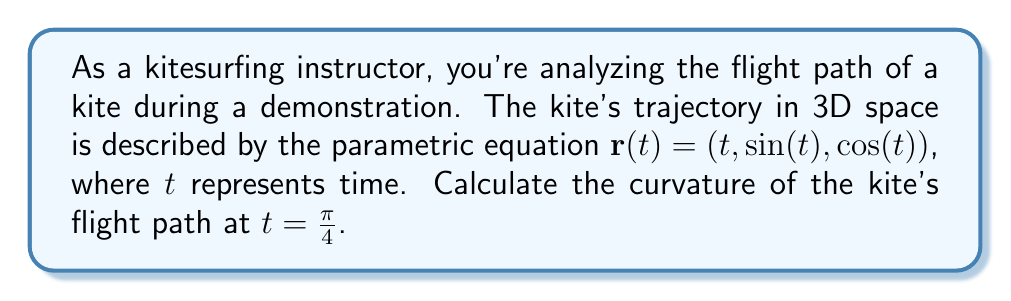Solve this math problem. To determine the curvature of the kite's flight path, we'll use differential geometry and follow these steps:

1) The curvature $\kappa$ is given by the formula:

   $$\kappa = \frac{|\mathbf{r}'(t) \times \mathbf{r}''(t)|}{|\mathbf{r}'(t)|^3}$$

2) First, let's calculate $\mathbf{r}'(t)$:
   $$\mathbf{r}'(t) = (1, \cos(t), -\sin(t))$$

3) Now, let's calculate $\mathbf{r}''(t)$:
   $$\mathbf{r}''(t) = (0, -\sin(t), -\cos(t))$$

4) At $t = \frac{\pi}{4}$, we have:
   $$\mathbf{r}'(\frac{\pi}{4}) = (1, \frac{\sqrt{2}}{2}, -\frac{\sqrt{2}}{2})$$
   $$\mathbf{r}''(\frac{\pi}{4}) = (0, -\frac{\sqrt{2}}{2}, -\frac{\sqrt{2}}{2})$$

5) Now, let's calculate the cross product $\mathbf{r}'(\frac{\pi}{4}) \times \mathbf{r}''(\frac{\pi}{4})$:

   $$\begin{vmatrix} 
   \mathbf{i} & \mathbf{j} & \mathbf{k} \\
   1 & \frac{\sqrt{2}}{2} & -\frac{\sqrt{2}}{2} \\
   0 & -\frac{\sqrt{2}}{2} & -\frac{\sqrt{2}}{2}
   \end{vmatrix} = (-\frac{1}{2}, -\frac{1}{2}, -\frac{\sqrt{2}}{2})$$

6) The magnitude of this cross product is:
   $$|\mathbf{r}'(\frac{\pi}{4}) \times \mathbf{r}''(\frac{\pi}{4})| = \sqrt{(-\frac{1}{2})^2 + (-\frac{1}{2})^2 + (-\frac{\sqrt{2}}{2})^2} = 1$$

7) Next, we calculate $|\mathbf{r}'(\frac{\pi}{4})|$:
   $$|\mathbf{r}'(\frac{\pi}{4})| = \sqrt{1^2 + (\frac{\sqrt{2}}{2})^2 + (-\frac{\sqrt{2}}{2})^2} = \sqrt{2}$$

8) Finally, we can calculate the curvature:
   $$\kappa = \frac{|\mathbf{r}'(\frac{\pi}{4}) \times \mathbf{r}''(\frac{\pi}{4})|}{|\mathbf{r}'(\frac{\pi}{4})|^3} = \frac{1}{(\sqrt{2})^3} = \frac{1}{2\sqrt{2}}$$
Answer: $\frac{1}{2\sqrt{2}}$ 